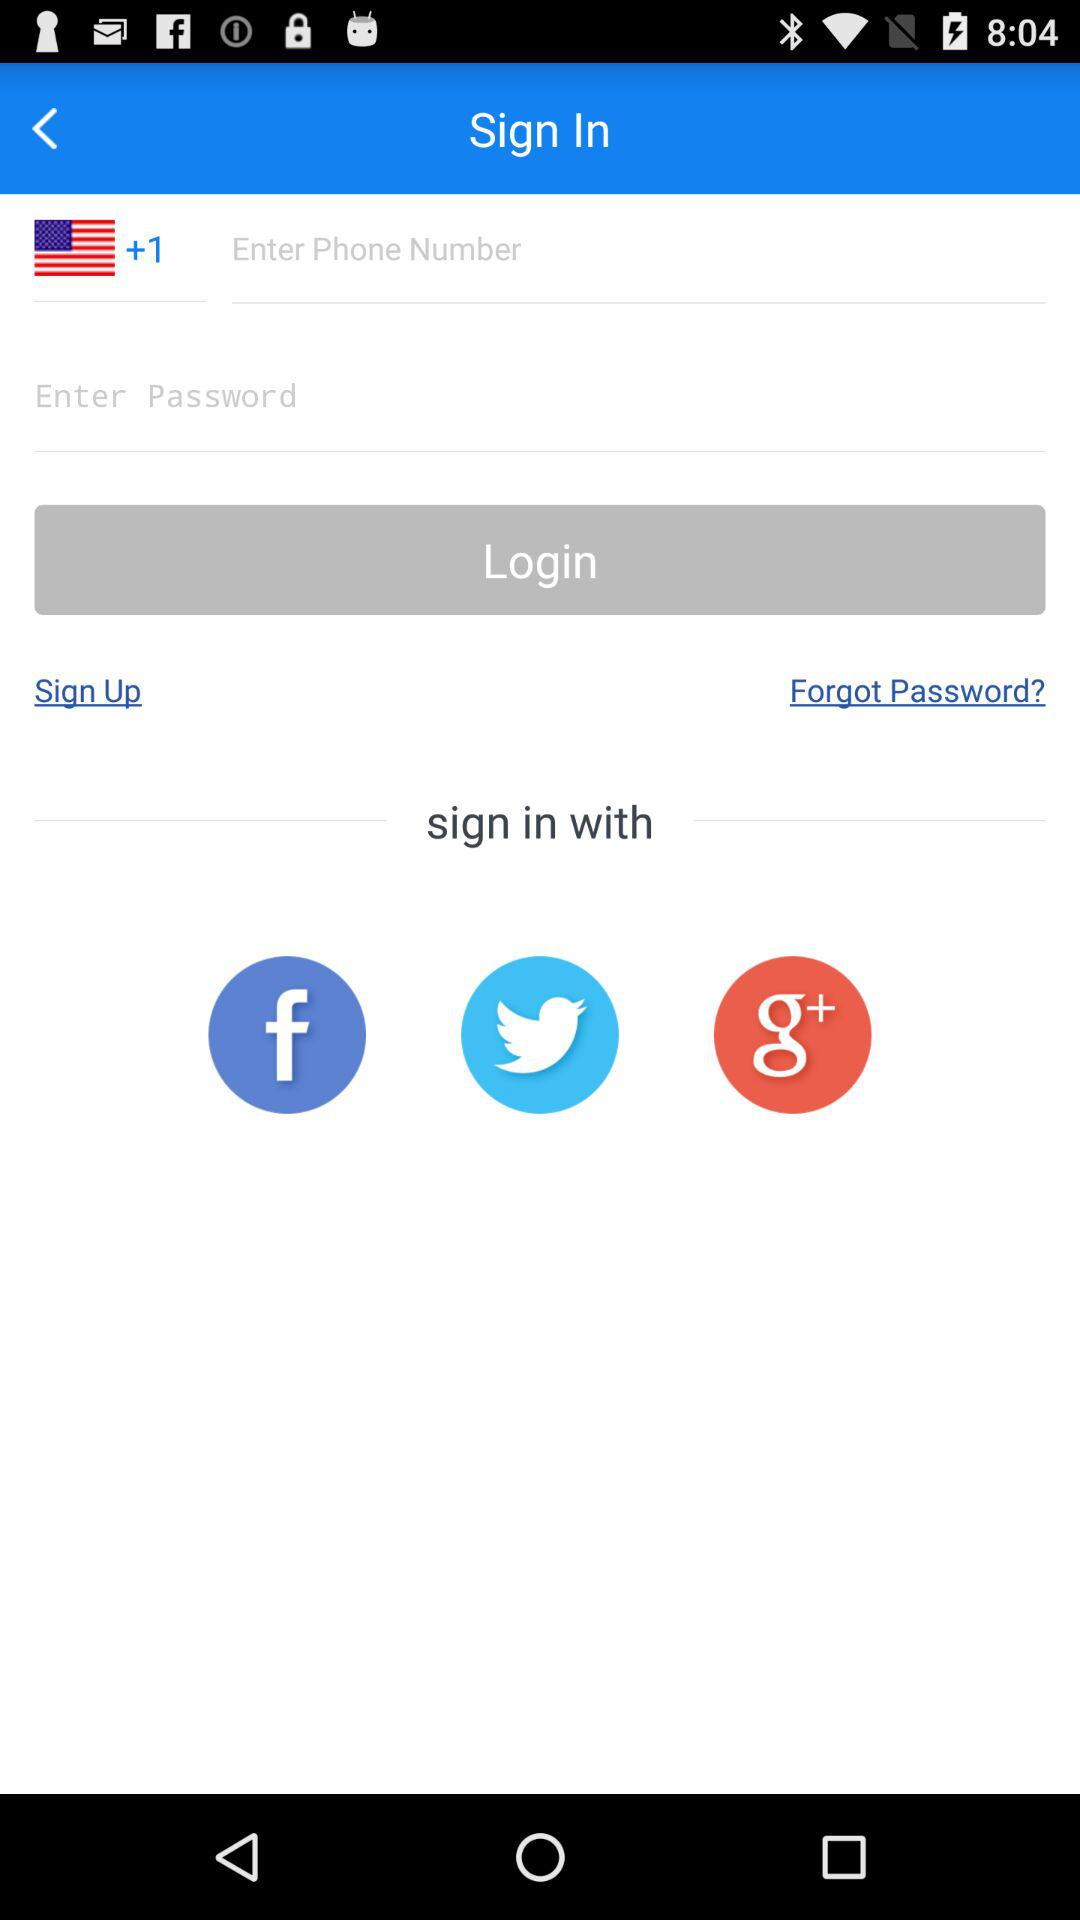Through what application can sign in to be done? The applications are "Facebook", "Twitter" and "Google plus". 